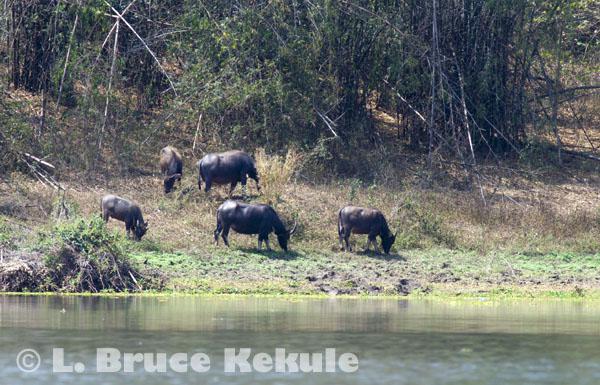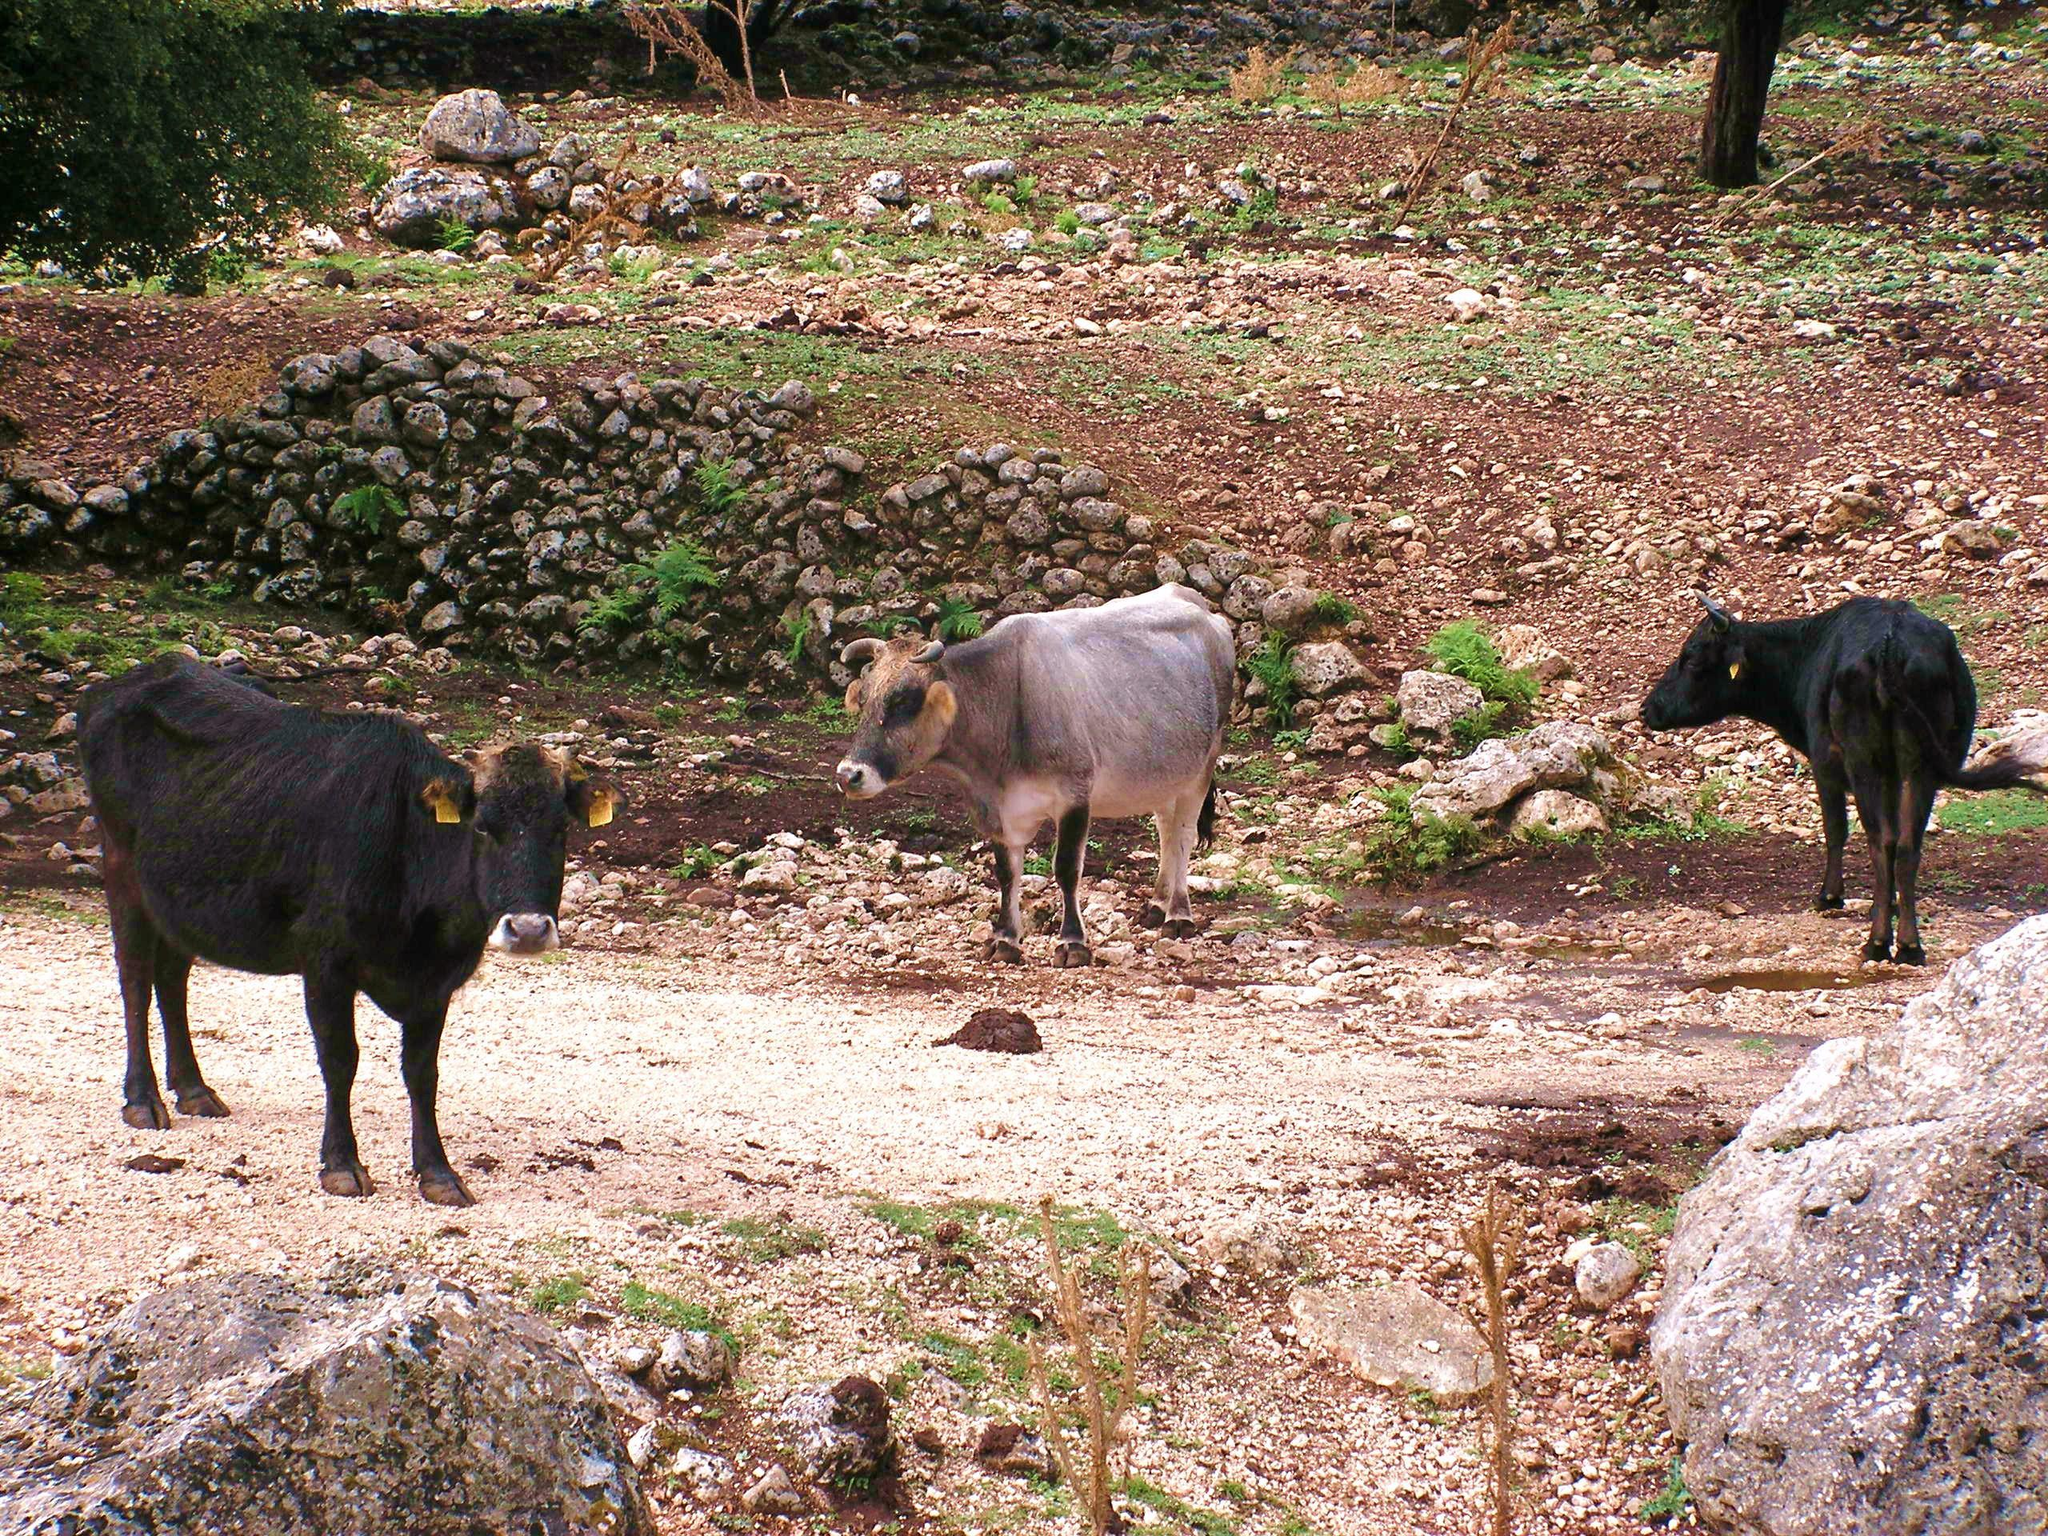The first image is the image on the left, the second image is the image on the right. For the images displayed, is the sentence "All animals in the right image have horns." factually correct? Answer yes or no. No. The first image is the image on the left, the second image is the image on the right. Assess this claim about the two images: "At least one animal is in the water in the image on the right.". Correct or not? Answer yes or no. No. 